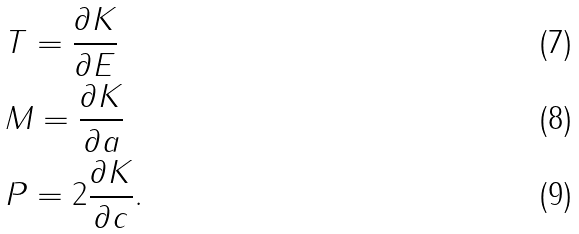Convert formula to latex. <formula><loc_0><loc_0><loc_500><loc_500>& T = \frac { \partial K } { \partial E } \\ & M = \frac { \partial K } { \partial a } \\ & P = 2 \frac { \partial K } { \partial c } .</formula> 